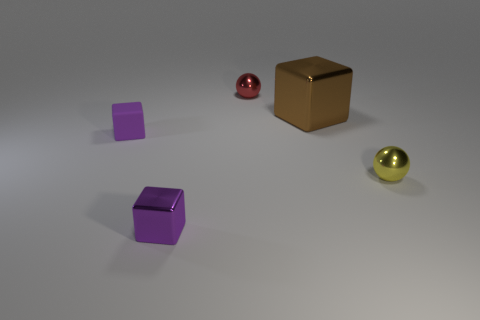Add 4 brown metal cylinders. How many objects exist? 9 Subtract all blocks. How many objects are left? 2 Subtract 0 brown cylinders. How many objects are left? 5 Subtract all tiny shiny spheres. Subtract all large blue metallic spheres. How many objects are left? 3 Add 2 large shiny blocks. How many large shiny blocks are left? 3 Add 3 gray things. How many gray things exist? 3 